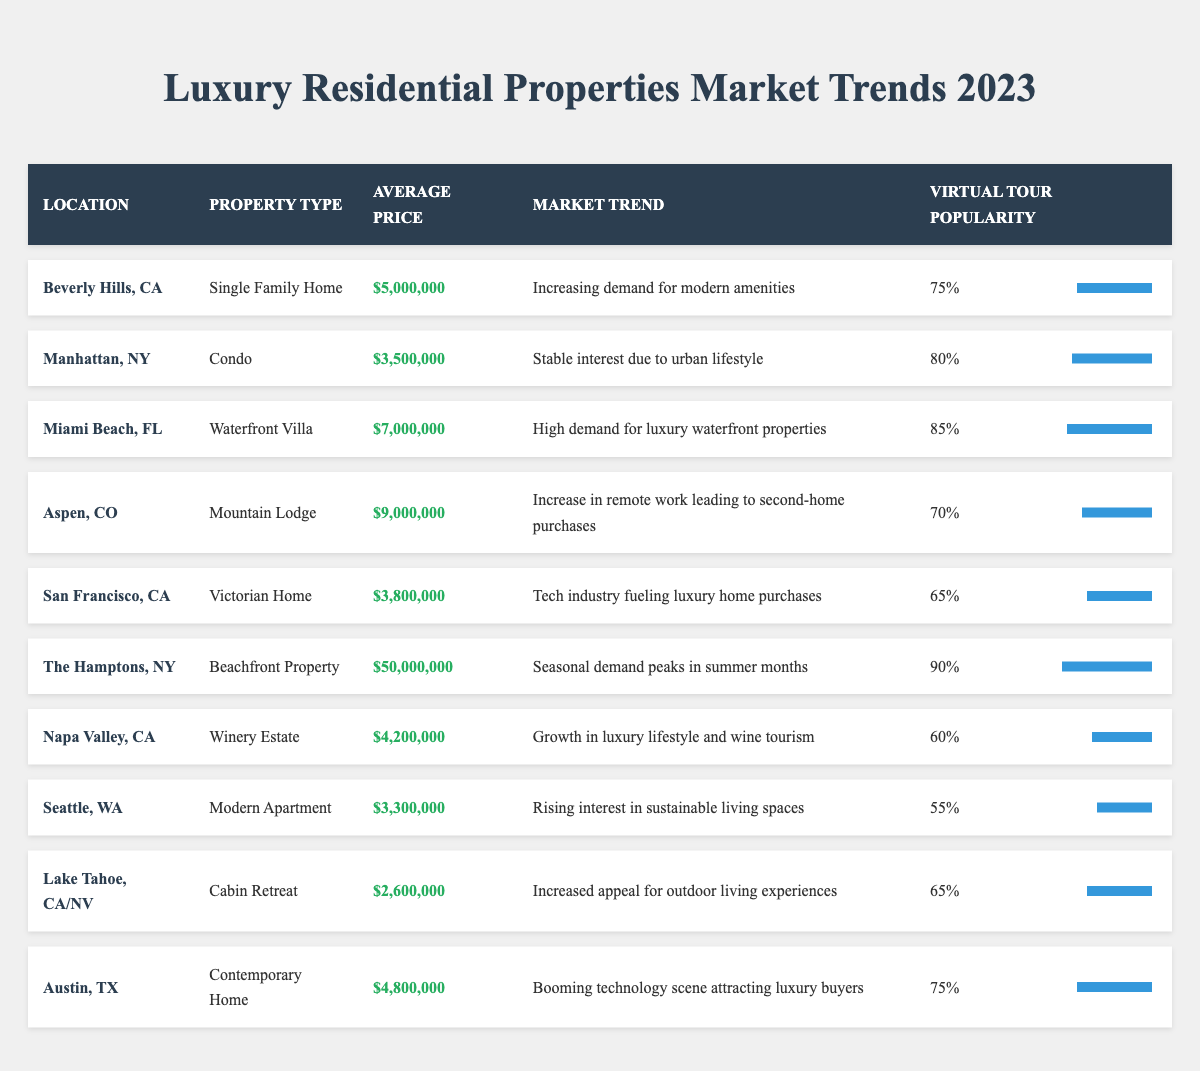What is the average price of luxury residential properties listed in 2023? To find the average price, add all the average prices together: $5,000,000 + $3,500,000 + $7,000,000 + $9,000,000 + $3,800,000 + $50,000,000 + $4,200,000 + $3,300,000 + $2,600,000 + $4,800,000 = $93,200,000. There are 10 properties, so divide the total price by 10: $93,200,000 / 10 = $9,320,000.
Answer: $9,320,000 Which property type has the highest virtual tour popularity percentage? By comparing the virtual tour popularity for each property type in the table, the highest percentage is 90% for the beachfront property in The Hamptons, NY.
Answer: Beachfront Property Are properties in Aspen, CO showing an increasing or decreasing market trend? The table states the market trend for Aspen, CO is "Increase in remote work leading to second-home purchases," which indicates an increasing trend.
Answer: Increasing What is the market trend for the luxury properties located in Miami Beach, FL? According to the table, the market trend for Miami Beach, FL is "High demand for luxury waterfront properties."
Answer: High demand for luxury waterfront properties How does the average price of properties in Napa Valley compare to those in San Francisco? Napa Valley has an average price of $4,200,000 while San Francisco has $3,800,000. The difference is $4,200,000 - $3,800,000 = $400,000, indicating Napa Valley properties are more expensive.
Answer: Napa Valley is $400,000 more expensive What percentage of virtual tour popularity does the luxury property in Seattle hold? The virtual tour popularity for the modern apartment in Seattle is 55%, as indicated in the table.
Answer: 55% Is the average price for luxury properties in Austin higher than that in Seattle? The average price in Austin is $4,800,000 and in Seattle, it is $3,300,000. Comparing these values shows that Austin's price is higher.
Answer: Yes What property type in The Hamptons has the highest average price compared to others? The Hamptons' beachfront property has an average price of $50,000,000, which is higher than the price of any other property listed in the table.
Answer: Beachfront Property If I wanted to target virtual tours with over 80% popularity, which locations would I consider? The properties with over 80% virtual tour popularity are Miami Beach, FL (85%) and The Hamptons, NY (90%).
Answer: Miami Beach and The Hamptons Which location has both the lowest virtual tour popularity percentage and the lowest average price? Seattle has the lowest virtual tour popularity at 55% and an average price of $3,300,000, making it the lowest in both categories.
Answer: Seattle 